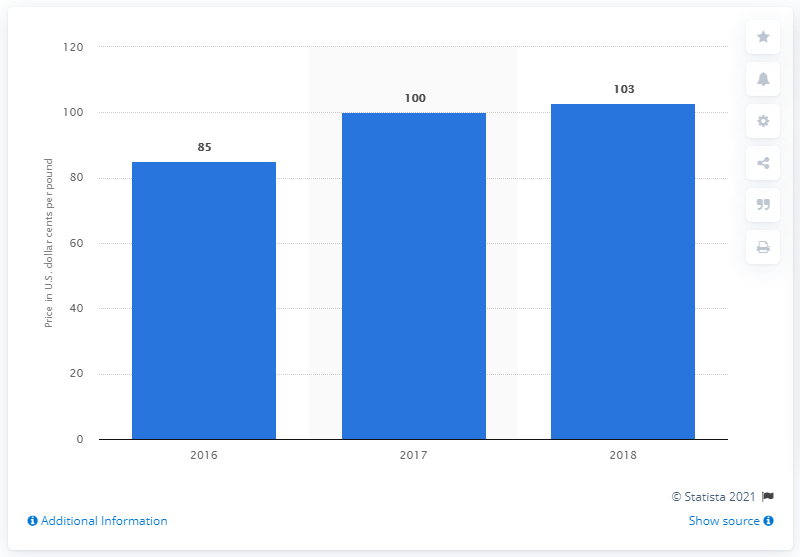Draw attention to some important aspects in this diagram. In 2016, the price of lead was $0.85 per pound in dollars and cents. In 2016, the average cash price of lead was <insert value>. 